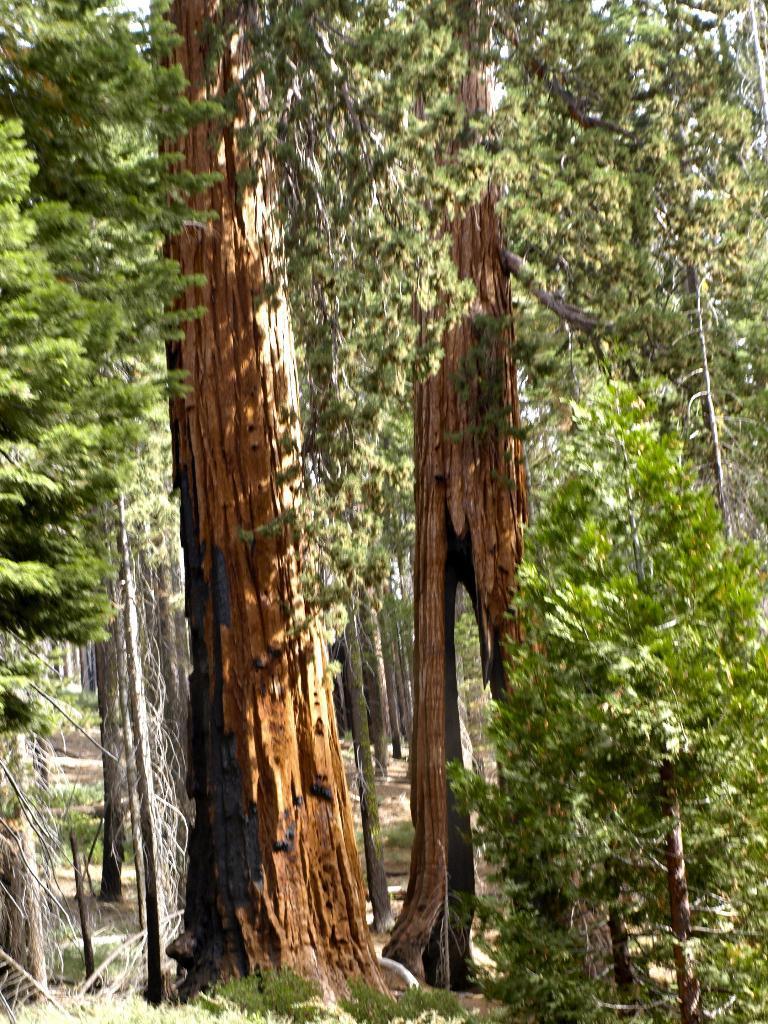Could you give a brief overview of what you see in this image? In this image we can see few trees and grass. 